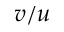Convert formula to latex. <formula><loc_0><loc_0><loc_500><loc_500>v / u</formula> 